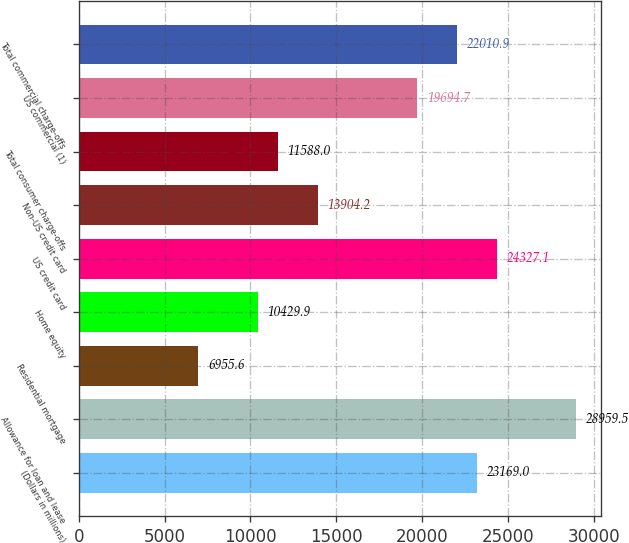<chart> <loc_0><loc_0><loc_500><loc_500><bar_chart><fcel>(Dollars in millions)<fcel>Allowance for loan and lease<fcel>Residential mortgage<fcel>Home equity<fcel>US credit card<fcel>Non-US credit card<fcel>Total consumer charge-offs<fcel>US commercial (1)<fcel>Total commercial charge-offs<nl><fcel>23169<fcel>28959.5<fcel>6955.6<fcel>10429.9<fcel>24327.1<fcel>13904.2<fcel>11588<fcel>19694.7<fcel>22010.9<nl></chart> 